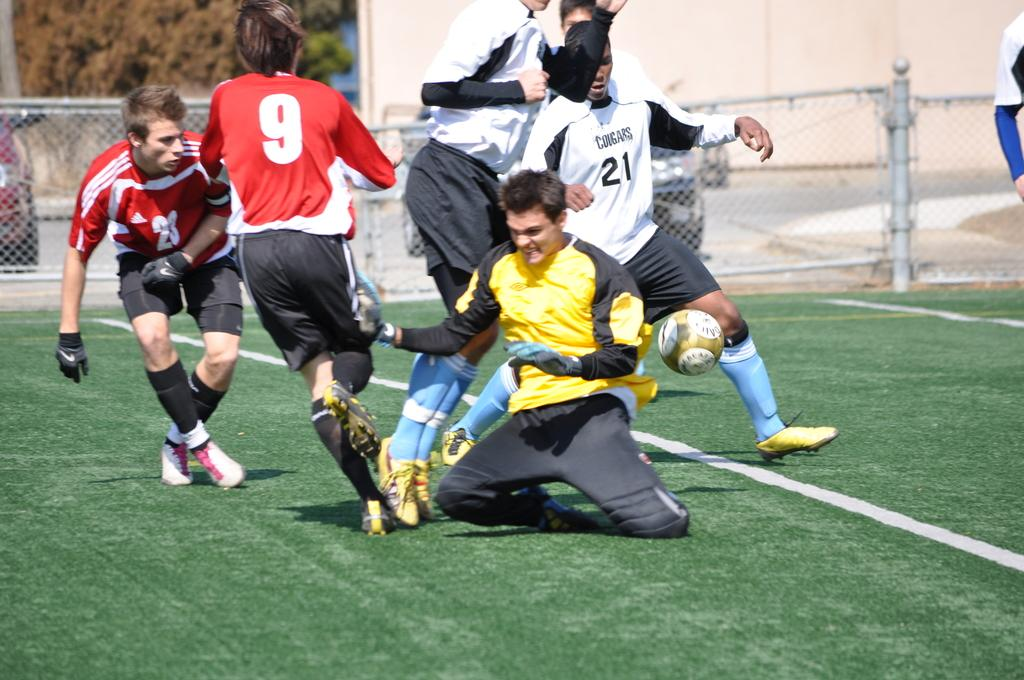Provide a one-sentence caption for the provided image. A group of soccer players compete and number 21 is about the strike the ball. 